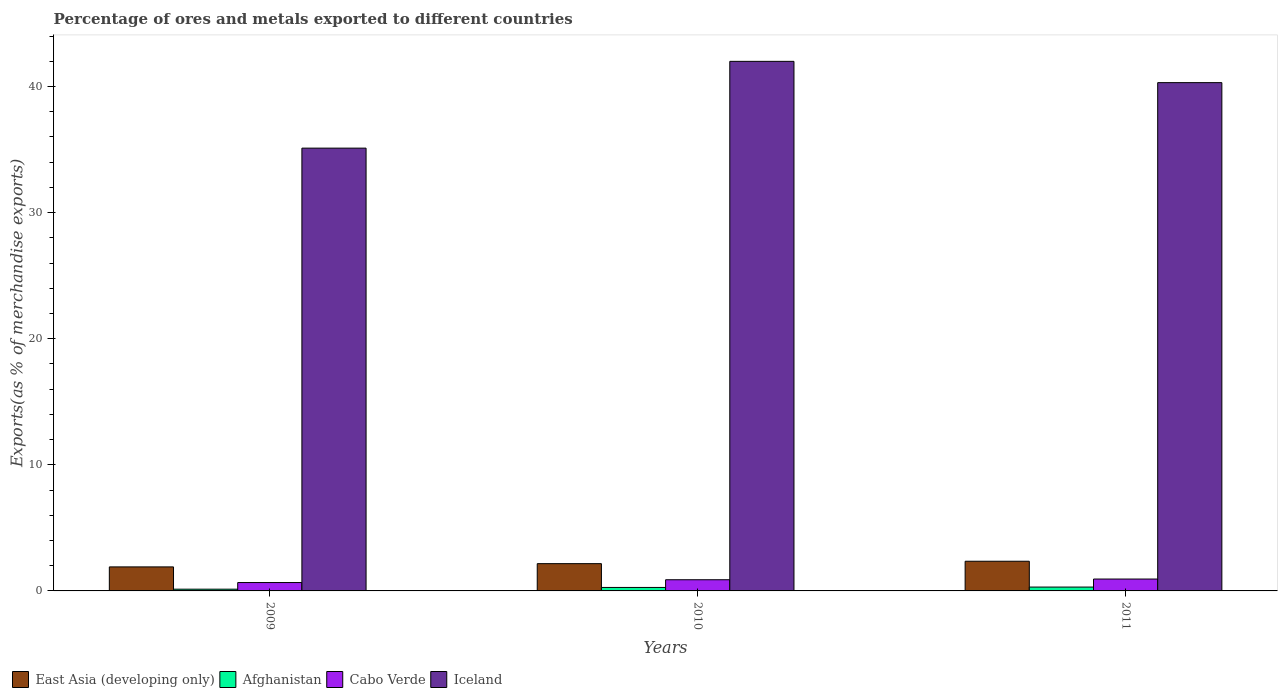How many different coloured bars are there?
Keep it short and to the point. 4. Are the number of bars per tick equal to the number of legend labels?
Your answer should be very brief. Yes. Are the number of bars on each tick of the X-axis equal?
Keep it short and to the point. Yes. How many bars are there on the 2nd tick from the right?
Keep it short and to the point. 4. What is the percentage of exports to different countries in Cabo Verde in 2009?
Your response must be concise. 0.67. Across all years, what is the maximum percentage of exports to different countries in Iceland?
Keep it short and to the point. 42. Across all years, what is the minimum percentage of exports to different countries in Iceland?
Provide a succinct answer. 35.12. In which year was the percentage of exports to different countries in Afghanistan maximum?
Your answer should be compact. 2011. In which year was the percentage of exports to different countries in East Asia (developing only) minimum?
Your response must be concise. 2009. What is the total percentage of exports to different countries in East Asia (developing only) in the graph?
Your answer should be compact. 6.42. What is the difference between the percentage of exports to different countries in Iceland in 2010 and that in 2011?
Provide a short and direct response. 1.69. What is the difference between the percentage of exports to different countries in Afghanistan in 2010 and the percentage of exports to different countries in Cabo Verde in 2009?
Ensure brevity in your answer.  -0.39. What is the average percentage of exports to different countries in East Asia (developing only) per year?
Make the answer very short. 2.14. In the year 2009, what is the difference between the percentage of exports to different countries in Iceland and percentage of exports to different countries in East Asia (developing only)?
Offer a very short reply. 33.21. What is the ratio of the percentage of exports to different countries in Iceland in 2009 to that in 2010?
Your answer should be very brief. 0.84. Is the percentage of exports to different countries in Iceland in 2009 less than that in 2011?
Your response must be concise. Yes. What is the difference between the highest and the second highest percentage of exports to different countries in Iceland?
Provide a succinct answer. 1.69. What is the difference between the highest and the lowest percentage of exports to different countries in East Asia (developing only)?
Ensure brevity in your answer.  0.45. In how many years, is the percentage of exports to different countries in Afghanistan greater than the average percentage of exports to different countries in Afghanistan taken over all years?
Your answer should be very brief. 2. What does the 1st bar from the left in 2010 represents?
Your response must be concise. East Asia (developing only). What does the 2nd bar from the right in 2011 represents?
Your answer should be compact. Cabo Verde. Is it the case that in every year, the sum of the percentage of exports to different countries in Afghanistan and percentage of exports to different countries in Iceland is greater than the percentage of exports to different countries in East Asia (developing only)?
Provide a short and direct response. Yes. Are all the bars in the graph horizontal?
Make the answer very short. No. How many years are there in the graph?
Give a very brief answer. 3. What is the difference between two consecutive major ticks on the Y-axis?
Provide a succinct answer. 10. Are the values on the major ticks of Y-axis written in scientific E-notation?
Offer a very short reply. No. Does the graph contain any zero values?
Your answer should be compact. No. Does the graph contain grids?
Provide a short and direct response. No. How many legend labels are there?
Your answer should be compact. 4. How are the legend labels stacked?
Offer a very short reply. Horizontal. What is the title of the graph?
Make the answer very short. Percentage of ores and metals exported to different countries. What is the label or title of the Y-axis?
Ensure brevity in your answer.  Exports(as % of merchandise exports). What is the Exports(as % of merchandise exports) of East Asia (developing only) in 2009?
Provide a succinct answer. 1.91. What is the Exports(as % of merchandise exports) of Afghanistan in 2009?
Offer a very short reply. 0.14. What is the Exports(as % of merchandise exports) of Cabo Verde in 2009?
Provide a succinct answer. 0.67. What is the Exports(as % of merchandise exports) of Iceland in 2009?
Your answer should be very brief. 35.12. What is the Exports(as % of merchandise exports) of East Asia (developing only) in 2010?
Offer a terse response. 2.16. What is the Exports(as % of merchandise exports) in Afghanistan in 2010?
Provide a short and direct response. 0.28. What is the Exports(as % of merchandise exports) of Cabo Verde in 2010?
Your answer should be very brief. 0.89. What is the Exports(as % of merchandise exports) in Iceland in 2010?
Your response must be concise. 42. What is the Exports(as % of merchandise exports) in East Asia (developing only) in 2011?
Offer a terse response. 2.35. What is the Exports(as % of merchandise exports) in Afghanistan in 2011?
Ensure brevity in your answer.  0.31. What is the Exports(as % of merchandise exports) in Cabo Verde in 2011?
Offer a very short reply. 0.94. What is the Exports(as % of merchandise exports) in Iceland in 2011?
Your answer should be compact. 40.31. Across all years, what is the maximum Exports(as % of merchandise exports) of East Asia (developing only)?
Provide a succinct answer. 2.35. Across all years, what is the maximum Exports(as % of merchandise exports) of Afghanistan?
Provide a short and direct response. 0.31. Across all years, what is the maximum Exports(as % of merchandise exports) of Cabo Verde?
Your answer should be very brief. 0.94. Across all years, what is the maximum Exports(as % of merchandise exports) of Iceland?
Give a very brief answer. 42. Across all years, what is the minimum Exports(as % of merchandise exports) of East Asia (developing only)?
Offer a terse response. 1.91. Across all years, what is the minimum Exports(as % of merchandise exports) of Afghanistan?
Your answer should be compact. 0.14. Across all years, what is the minimum Exports(as % of merchandise exports) in Cabo Verde?
Keep it short and to the point. 0.67. Across all years, what is the minimum Exports(as % of merchandise exports) of Iceland?
Provide a short and direct response. 35.12. What is the total Exports(as % of merchandise exports) in East Asia (developing only) in the graph?
Your answer should be compact. 6.42. What is the total Exports(as % of merchandise exports) of Afghanistan in the graph?
Give a very brief answer. 0.72. What is the total Exports(as % of merchandise exports) of Cabo Verde in the graph?
Offer a very short reply. 2.49. What is the total Exports(as % of merchandise exports) in Iceland in the graph?
Give a very brief answer. 117.43. What is the difference between the Exports(as % of merchandise exports) of East Asia (developing only) in 2009 and that in 2010?
Give a very brief answer. -0.26. What is the difference between the Exports(as % of merchandise exports) of Afghanistan in 2009 and that in 2010?
Offer a very short reply. -0.14. What is the difference between the Exports(as % of merchandise exports) of Cabo Verde in 2009 and that in 2010?
Your answer should be very brief. -0.22. What is the difference between the Exports(as % of merchandise exports) in Iceland in 2009 and that in 2010?
Your answer should be compact. -6.88. What is the difference between the Exports(as % of merchandise exports) of East Asia (developing only) in 2009 and that in 2011?
Offer a very short reply. -0.45. What is the difference between the Exports(as % of merchandise exports) of Afghanistan in 2009 and that in 2011?
Give a very brief answer. -0.17. What is the difference between the Exports(as % of merchandise exports) of Cabo Verde in 2009 and that in 2011?
Ensure brevity in your answer.  -0.28. What is the difference between the Exports(as % of merchandise exports) of Iceland in 2009 and that in 2011?
Keep it short and to the point. -5.19. What is the difference between the Exports(as % of merchandise exports) of East Asia (developing only) in 2010 and that in 2011?
Offer a very short reply. -0.19. What is the difference between the Exports(as % of merchandise exports) in Afghanistan in 2010 and that in 2011?
Make the answer very short. -0.03. What is the difference between the Exports(as % of merchandise exports) in Cabo Verde in 2010 and that in 2011?
Give a very brief answer. -0.06. What is the difference between the Exports(as % of merchandise exports) in Iceland in 2010 and that in 2011?
Your answer should be very brief. 1.69. What is the difference between the Exports(as % of merchandise exports) in East Asia (developing only) in 2009 and the Exports(as % of merchandise exports) in Afghanistan in 2010?
Your answer should be compact. 1.63. What is the difference between the Exports(as % of merchandise exports) of East Asia (developing only) in 2009 and the Exports(as % of merchandise exports) of Cabo Verde in 2010?
Your answer should be very brief. 1.02. What is the difference between the Exports(as % of merchandise exports) of East Asia (developing only) in 2009 and the Exports(as % of merchandise exports) of Iceland in 2010?
Give a very brief answer. -40.09. What is the difference between the Exports(as % of merchandise exports) of Afghanistan in 2009 and the Exports(as % of merchandise exports) of Cabo Verde in 2010?
Keep it short and to the point. -0.75. What is the difference between the Exports(as % of merchandise exports) in Afghanistan in 2009 and the Exports(as % of merchandise exports) in Iceland in 2010?
Provide a succinct answer. -41.86. What is the difference between the Exports(as % of merchandise exports) in Cabo Verde in 2009 and the Exports(as % of merchandise exports) in Iceland in 2010?
Make the answer very short. -41.33. What is the difference between the Exports(as % of merchandise exports) of East Asia (developing only) in 2009 and the Exports(as % of merchandise exports) of Afghanistan in 2011?
Give a very brief answer. 1.6. What is the difference between the Exports(as % of merchandise exports) of East Asia (developing only) in 2009 and the Exports(as % of merchandise exports) of Cabo Verde in 2011?
Ensure brevity in your answer.  0.96. What is the difference between the Exports(as % of merchandise exports) in East Asia (developing only) in 2009 and the Exports(as % of merchandise exports) in Iceland in 2011?
Make the answer very short. -38.41. What is the difference between the Exports(as % of merchandise exports) of Afghanistan in 2009 and the Exports(as % of merchandise exports) of Cabo Verde in 2011?
Ensure brevity in your answer.  -0.8. What is the difference between the Exports(as % of merchandise exports) in Afghanistan in 2009 and the Exports(as % of merchandise exports) in Iceland in 2011?
Keep it short and to the point. -40.17. What is the difference between the Exports(as % of merchandise exports) of Cabo Verde in 2009 and the Exports(as % of merchandise exports) of Iceland in 2011?
Make the answer very short. -39.65. What is the difference between the Exports(as % of merchandise exports) in East Asia (developing only) in 2010 and the Exports(as % of merchandise exports) in Afghanistan in 2011?
Provide a short and direct response. 1.86. What is the difference between the Exports(as % of merchandise exports) in East Asia (developing only) in 2010 and the Exports(as % of merchandise exports) in Cabo Verde in 2011?
Your answer should be very brief. 1.22. What is the difference between the Exports(as % of merchandise exports) in East Asia (developing only) in 2010 and the Exports(as % of merchandise exports) in Iceland in 2011?
Offer a very short reply. -38.15. What is the difference between the Exports(as % of merchandise exports) in Afghanistan in 2010 and the Exports(as % of merchandise exports) in Cabo Verde in 2011?
Make the answer very short. -0.67. What is the difference between the Exports(as % of merchandise exports) of Afghanistan in 2010 and the Exports(as % of merchandise exports) of Iceland in 2011?
Your answer should be compact. -40.04. What is the difference between the Exports(as % of merchandise exports) of Cabo Verde in 2010 and the Exports(as % of merchandise exports) of Iceland in 2011?
Offer a very short reply. -39.42. What is the average Exports(as % of merchandise exports) of East Asia (developing only) per year?
Make the answer very short. 2.14. What is the average Exports(as % of merchandise exports) of Afghanistan per year?
Keep it short and to the point. 0.24. What is the average Exports(as % of merchandise exports) of Cabo Verde per year?
Your answer should be very brief. 0.83. What is the average Exports(as % of merchandise exports) in Iceland per year?
Provide a succinct answer. 39.14. In the year 2009, what is the difference between the Exports(as % of merchandise exports) in East Asia (developing only) and Exports(as % of merchandise exports) in Afghanistan?
Your answer should be compact. 1.77. In the year 2009, what is the difference between the Exports(as % of merchandise exports) in East Asia (developing only) and Exports(as % of merchandise exports) in Cabo Verde?
Give a very brief answer. 1.24. In the year 2009, what is the difference between the Exports(as % of merchandise exports) of East Asia (developing only) and Exports(as % of merchandise exports) of Iceland?
Your response must be concise. -33.21. In the year 2009, what is the difference between the Exports(as % of merchandise exports) of Afghanistan and Exports(as % of merchandise exports) of Cabo Verde?
Offer a terse response. -0.53. In the year 2009, what is the difference between the Exports(as % of merchandise exports) in Afghanistan and Exports(as % of merchandise exports) in Iceland?
Provide a short and direct response. -34.98. In the year 2009, what is the difference between the Exports(as % of merchandise exports) of Cabo Verde and Exports(as % of merchandise exports) of Iceland?
Give a very brief answer. -34.45. In the year 2010, what is the difference between the Exports(as % of merchandise exports) in East Asia (developing only) and Exports(as % of merchandise exports) in Afghanistan?
Ensure brevity in your answer.  1.89. In the year 2010, what is the difference between the Exports(as % of merchandise exports) in East Asia (developing only) and Exports(as % of merchandise exports) in Cabo Verde?
Provide a short and direct response. 1.28. In the year 2010, what is the difference between the Exports(as % of merchandise exports) of East Asia (developing only) and Exports(as % of merchandise exports) of Iceland?
Your answer should be very brief. -39.84. In the year 2010, what is the difference between the Exports(as % of merchandise exports) in Afghanistan and Exports(as % of merchandise exports) in Cabo Verde?
Provide a succinct answer. -0.61. In the year 2010, what is the difference between the Exports(as % of merchandise exports) in Afghanistan and Exports(as % of merchandise exports) in Iceland?
Give a very brief answer. -41.72. In the year 2010, what is the difference between the Exports(as % of merchandise exports) of Cabo Verde and Exports(as % of merchandise exports) of Iceland?
Make the answer very short. -41.11. In the year 2011, what is the difference between the Exports(as % of merchandise exports) of East Asia (developing only) and Exports(as % of merchandise exports) of Afghanistan?
Offer a very short reply. 2.05. In the year 2011, what is the difference between the Exports(as % of merchandise exports) of East Asia (developing only) and Exports(as % of merchandise exports) of Cabo Verde?
Make the answer very short. 1.41. In the year 2011, what is the difference between the Exports(as % of merchandise exports) in East Asia (developing only) and Exports(as % of merchandise exports) in Iceland?
Provide a succinct answer. -37.96. In the year 2011, what is the difference between the Exports(as % of merchandise exports) in Afghanistan and Exports(as % of merchandise exports) in Cabo Verde?
Give a very brief answer. -0.64. In the year 2011, what is the difference between the Exports(as % of merchandise exports) in Afghanistan and Exports(as % of merchandise exports) in Iceland?
Make the answer very short. -40.01. In the year 2011, what is the difference between the Exports(as % of merchandise exports) of Cabo Verde and Exports(as % of merchandise exports) of Iceland?
Your answer should be very brief. -39.37. What is the ratio of the Exports(as % of merchandise exports) of East Asia (developing only) in 2009 to that in 2010?
Your answer should be very brief. 0.88. What is the ratio of the Exports(as % of merchandise exports) of Afghanistan in 2009 to that in 2010?
Keep it short and to the point. 0.5. What is the ratio of the Exports(as % of merchandise exports) in Cabo Verde in 2009 to that in 2010?
Your answer should be very brief. 0.75. What is the ratio of the Exports(as % of merchandise exports) of Iceland in 2009 to that in 2010?
Keep it short and to the point. 0.84. What is the ratio of the Exports(as % of merchandise exports) of East Asia (developing only) in 2009 to that in 2011?
Provide a short and direct response. 0.81. What is the ratio of the Exports(as % of merchandise exports) of Afghanistan in 2009 to that in 2011?
Your response must be concise. 0.45. What is the ratio of the Exports(as % of merchandise exports) in Cabo Verde in 2009 to that in 2011?
Offer a very short reply. 0.71. What is the ratio of the Exports(as % of merchandise exports) of Iceland in 2009 to that in 2011?
Your answer should be compact. 0.87. What is the ratio of the Exports(as % of merchandise exports) of East Asia (developing only) in 2010 to that in 2011?
Keep it short and to the point. 0.92. What is the ratio of the Exports(as % of merchandise exports) of Afghanistan in 2010 to that in 2011?
Provide a succinct answer. 0.9. What is the ratio of the Exports(as % of merchandise exports) of Cabo Verde in 2010 to that in 2011?
Ensure brevity in your answer.  0.94. What is the ratio of the Exports(as % of merchandise exports) in Iceland in 2010 to that in 2011?
Provide a succinct answer. 1.04. What is the difference between the highest and the second highest Exports(as % of merchandise exports) of East Asia (developing only)?
Provide a short and direct response. 0.19. What is the difference between the highest and the second highest Exports(as % of merchandise exports) of Afghanistan?
Offer a terse response. 0.03. What is the difference between the highest and the second highest Exports(as % of merchandise exports) of Cabo Verde?
Offer a very short reply. 0.06. What is the difference between the highest and the second highest Exports(as % of merchandise exports) of Iceland?
Your response must be concise. 1.69. What is the difference between the highest and the lowest Exports(as % of merchandise exports) of East Asia (developing only)?
Ensure brevity in your answer.  0.45. What is the difference between the highest and the lowest Exports(as % of merchandise exports) of Afghanistan?
Your response must be concise. 0.17. What is the difference between the highest and the lowest Exports(as % of merchandise exports) in Cabo Verde?
Make the answer very short. 0.28. What is the difference between the highest and the lowest Exports(as % of merchandise exports) of Iceland?
Provide a short and direct response. 6.88. 